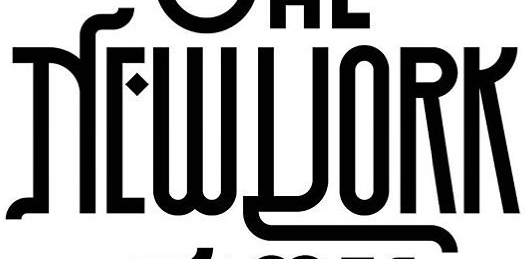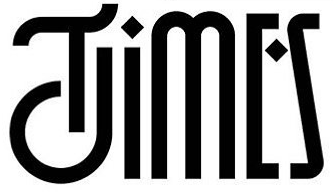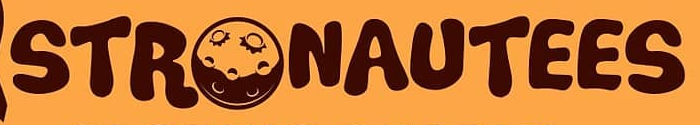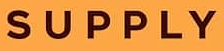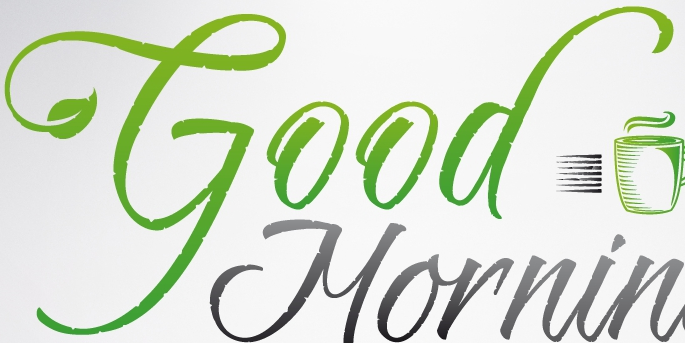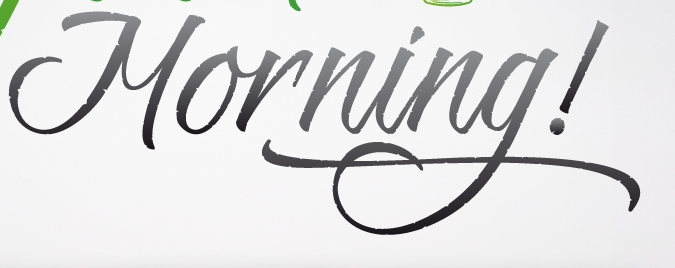What text appears in these images from left to right, separated by a semicolon? NEWYORK; TIMES; STRONAUTEES; SUPPLY; Good; Morning! 